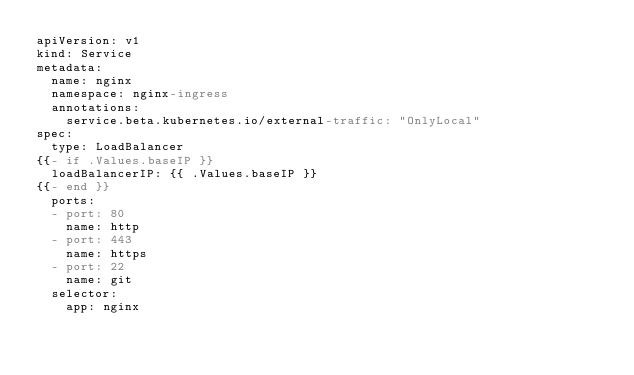<code> <loc_0><loc_0><loc_500><loc_500><_YAML_>apiVersion: v1
kind: Service
metadata:
  name: nginx
  namespace: nginx-ingress
  annotations:
    service.beta.kubernetes.io/external-traffic: "OnlyLocal"
spec:
  type: LoadBalancer
{{- if .Values.baseIP }}
  loadBalancerIP: {{ .Values.baseIP }}
{{- end }}
  ports:
  - port: 80
    name: http
  - port: 443
    name: https
  - port: 22
    name: git
  selector:
    app: nginx
</code> 